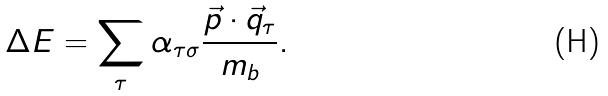<formula> <loc_0><loc_0><loc_500><loc_500>\Delta E = \sum _ { \tau } \alpha _ { \tau \sigma } \frac { \vec { p } \cdot \vec { q } _ { \tau } } { m _ { b } } .</formula> 